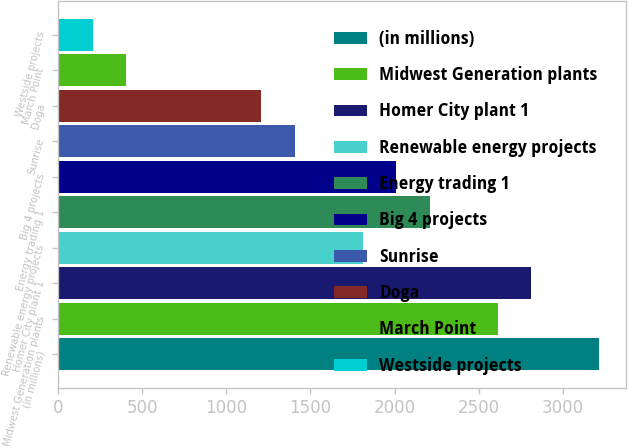Convert chart to OTSL. <chart><loc_0><loc_0><loc_500><loc_500><bar_chart><fcel>(in millions)<fcel>Midwest Generation plants<fcel>Homer City plant 1<fcel>Renewable energy projects<fcel>Energy trading 1<fcel>Big 4 projects<fcel>Sunrise<fcel>Doga<fcel>March Point<fcel>Westside projects<nl><fcel>3214.6<fcel>2612.8<fcel>2813.4<fcel>1810.4<fcel>2211.6<fcel>2011<fcel>1409.2<fcel>1208.6<fcel>406.2<fcel>205.6<nl></chart> 